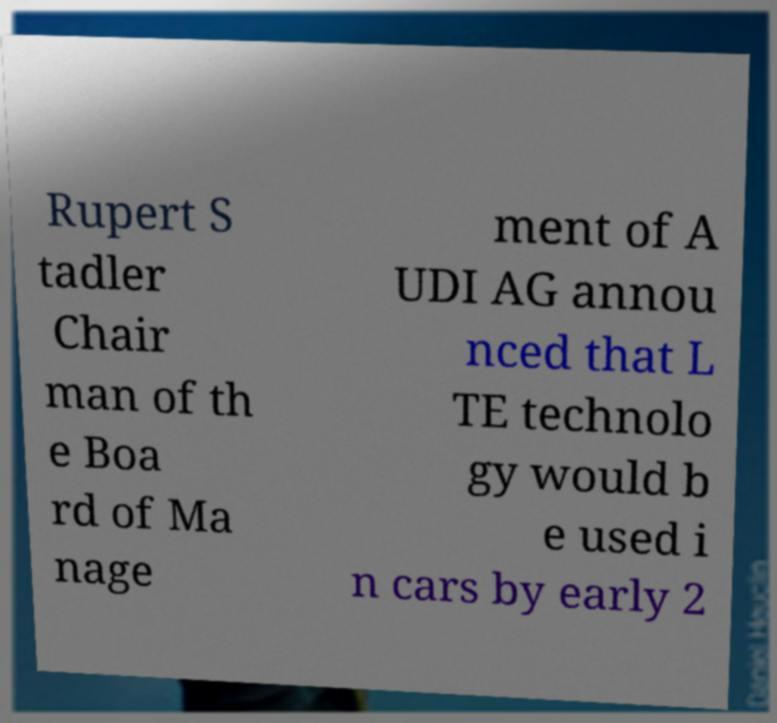Can you read and provide the text displayed in the image?This photo seems to have some interesting text. Can you extract and type it out for me? Rupert S tadler Chair man of th e Boa rd of Ma nage ment of A UDI AG annou nced that L TE technolo gy would b e used i n cars by early 2 